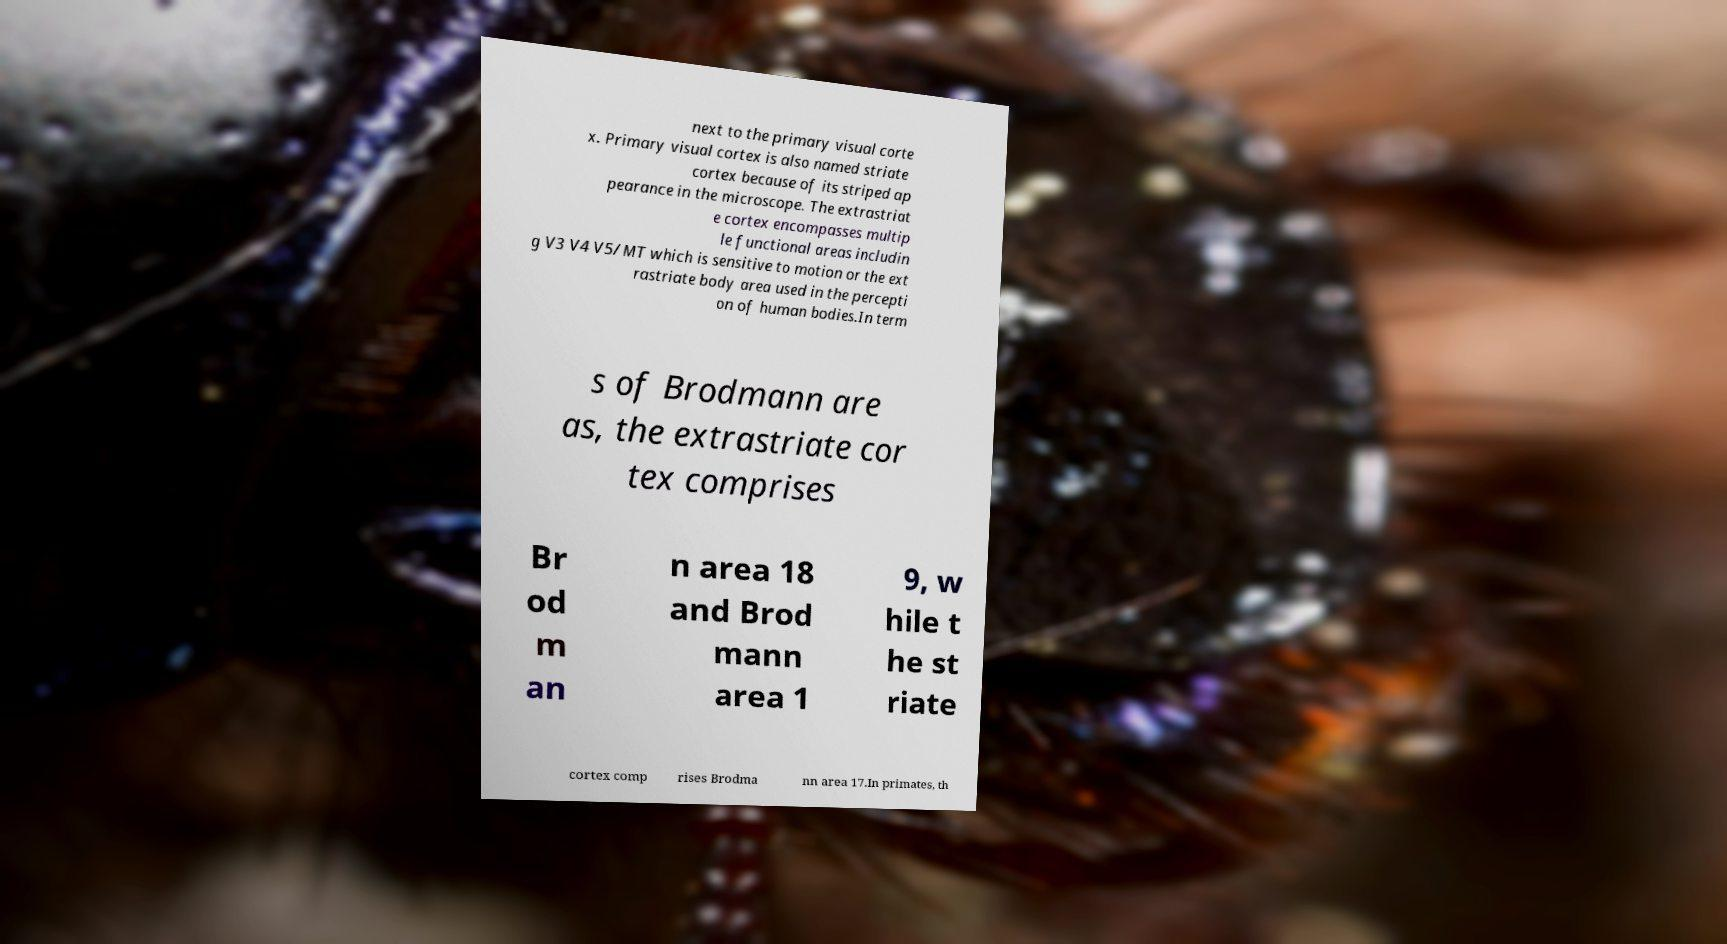There's text embedded in this image that I need extracted. Can you transcribe it verbatim? next to the primary visual corte x. Primary visual cortex is also named striate cortex because of its striped ap pearance in the microscope. The extrastriat e cortex encompasses multip le functional areas includin g V3 V4 V5/MT which is sensitive to motion or the ext rastriate body area used in the percepti on of human bodies.In term s of Brodmann are as, the extrastriate cor tex comprises Br od m an n area 18 and Brod mann area 1 9, w hile t he st riate cortex comp rises Brodma nn area 17.In primates, th 